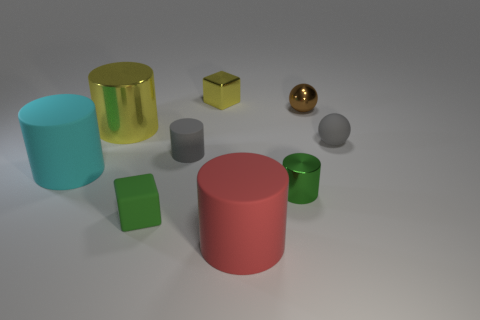What number of shiny things are either tiny green objects or big yellow things?
Make the answer very short. 2. Is there a tiny green rubber cube in front of the large cylinder in front of the metallic thing that is in front of the cyan object?
Your answer should be compact. No. What color is the rubber ball?
Your answer should be very brief. Gray. There is a metal thing that is in front of the yellow cylinder; is it the same shape as the small yellow shiny thing?
Make the answer very short. No. How many objects are either big purple rubber spheres or objects that are right of the big yellow thing?
Your response must be concise. 7. Are the big object to the right of the large shiny thing and the big cyan object made of the same material?
Your answer should be very brief. Yes. What material is the yellow cube that is behind the tiny shiny object on the right side of the green shiny object?
Provide a short and direct response. Metal. Is the number of cyan cylinders right of the large cyan matte cylinder greater than the number of brown shiny spheres that are to the left of the yellow cube?
Provide a short and direct response. No. What size is the brown metallic ball?
Provide a succinct answer. Small. Does the large cylinder that is behind the cyan object have the same color as the tiny metallic block?
Your response must be concise. Yes. 